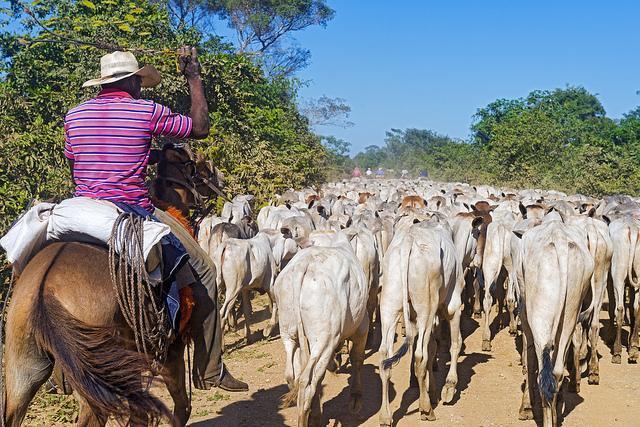How many cows are visible?
Give a very brief answer. 8. 